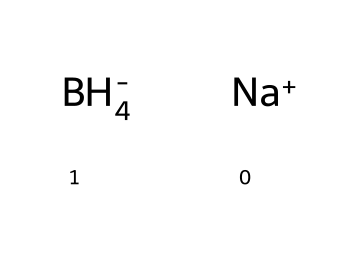What is the oxidation state of boron in sodium borohydride? The oxidation state is calculated based on the known charges of the other atoms. Hydrogen typically has an oxidation state of +1, and there are four hydrogens contributing a total of +4. Sodium has an oxidation state of +1. Thus, for the compound to be neutral, boron's oxidation state must be -3 to balance the +5 from sodium and hydrogens.
Answer: -3 How many hydrogen atoms are present in sodium borohydride? The structure shows a total of four hydrogen atoms attached to the boron atom, thus indicated directly by the formula BH4.
Answer: 4 What type of chemical interaction does sodium borohydride primarily participate in? This chemical primarily acts as a reducing agent, which means it donates electrons to other substances, commonly in reduction reactions. This is typical for compounds containing boron-hydride bonds.
Answer: reduction What is the total number of atoms in sodium borohydride according to its formula? The components include one sodium atom, one boron atom, and four hydrogen atoms, leading to a total of six atoms (1 + 1 + 4 = 6).
Answer: 6 Which element contributes the larger part of the charge in sodium borohydride? The charge would be primarily contributed by boron as it is part of the anionic hydride (BH4-), which is the negatively charged portion of the compound. Sodium, being a cation (+), balances this charge.
Answer: boron Is sodium borohydride a stable compound? Yes, sodium borohydride is generally considered stable under normal conditions but can decompose under certain conditions such as high temperature or reactions with strong acids.
Answer: stable 